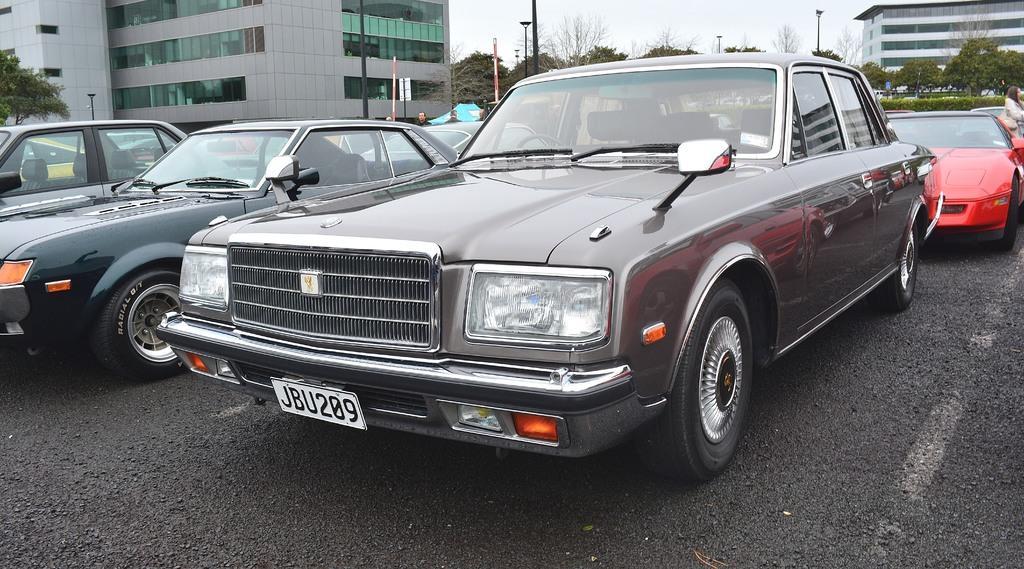Can you describe this image briefly? This image is taken outdoors. At the bottom of the image there is a road. In the middle of the image a few cars are parked on the road. In the background there are a few people. There are many trees and plants and there are a few buildings and poles. At the top of the image there is a sky. 